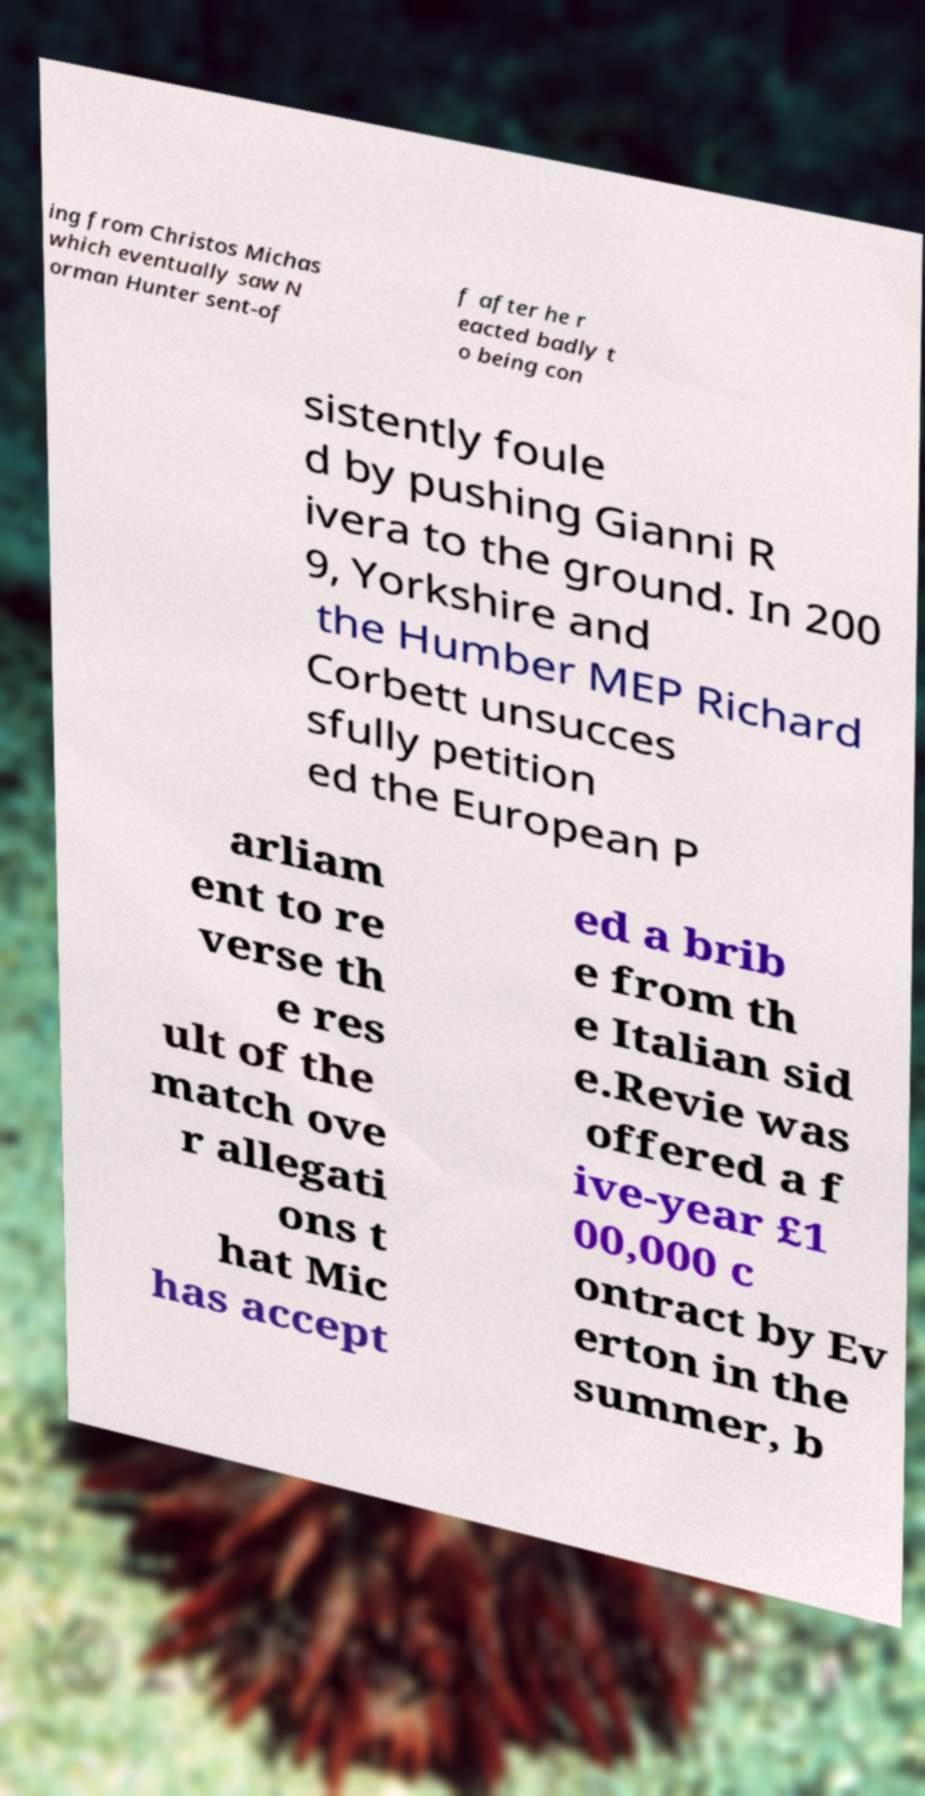Please identify and transcribe the text found in this image. ing from Christos Michas which eventually saw N orman Hunter sent-of f after he r eacted badly t o being con sistently foule d by pushing Gianni R ivera to the ground. In 200 9, Yorkshire and the Humber MEP Richard Corbett unsucces sfully petition ed the European P arliam ent to re verse th e res ult of the match ove r allegati ons t hat Mic has accept ed a brib e from th e Italian sid e.Revie was offered a f ive-year £1 00,000 c ontract by Ev erton in the summer, b 